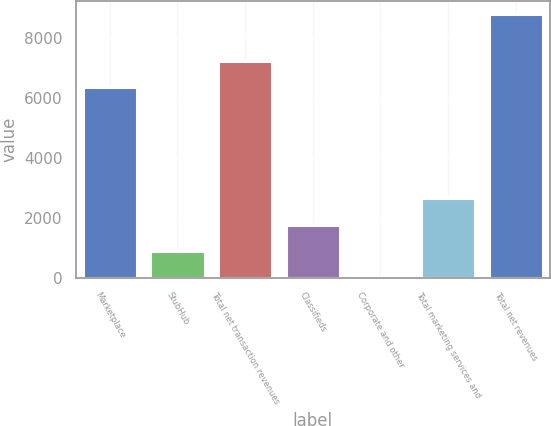Convert chart to OTSL. <chart><loc_0><loc_0><loc_500><loc_500><bar_chart><fcel>Marketplace<fcel>StubHub<fcel>Total net transaction revenues<fcel>Classifieds<fcel>Corporate and other<fcel>Total marketing services and<fcel>Total net revenues<nl><fcel>6351<fcel>887.1<fcel>7229.1<fcel>1765.2<fcel>9<fcel>2643.3<fcel>8790<nl></chart> 